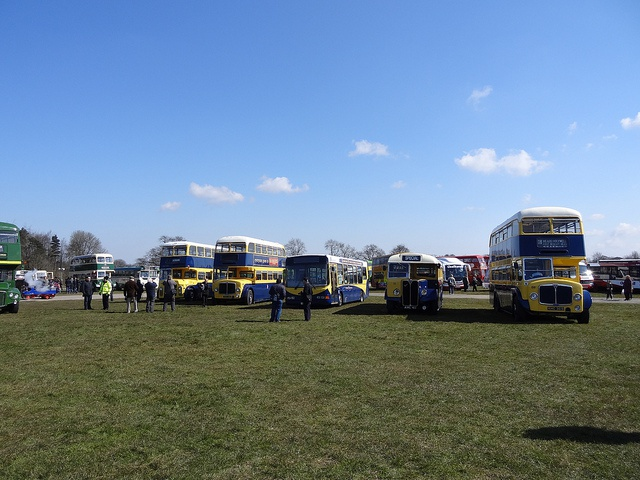Describe the objects in this image and their specific colors. I can see bus in gray, black, olive, and navy tones, bus in gray, black, navy, and darkgray tones, bus in gray, black, navy, and darkgray tones, bus in gray, black, darkgreen, and navy tones, and bus in gray, black, and navy tones in this image. 